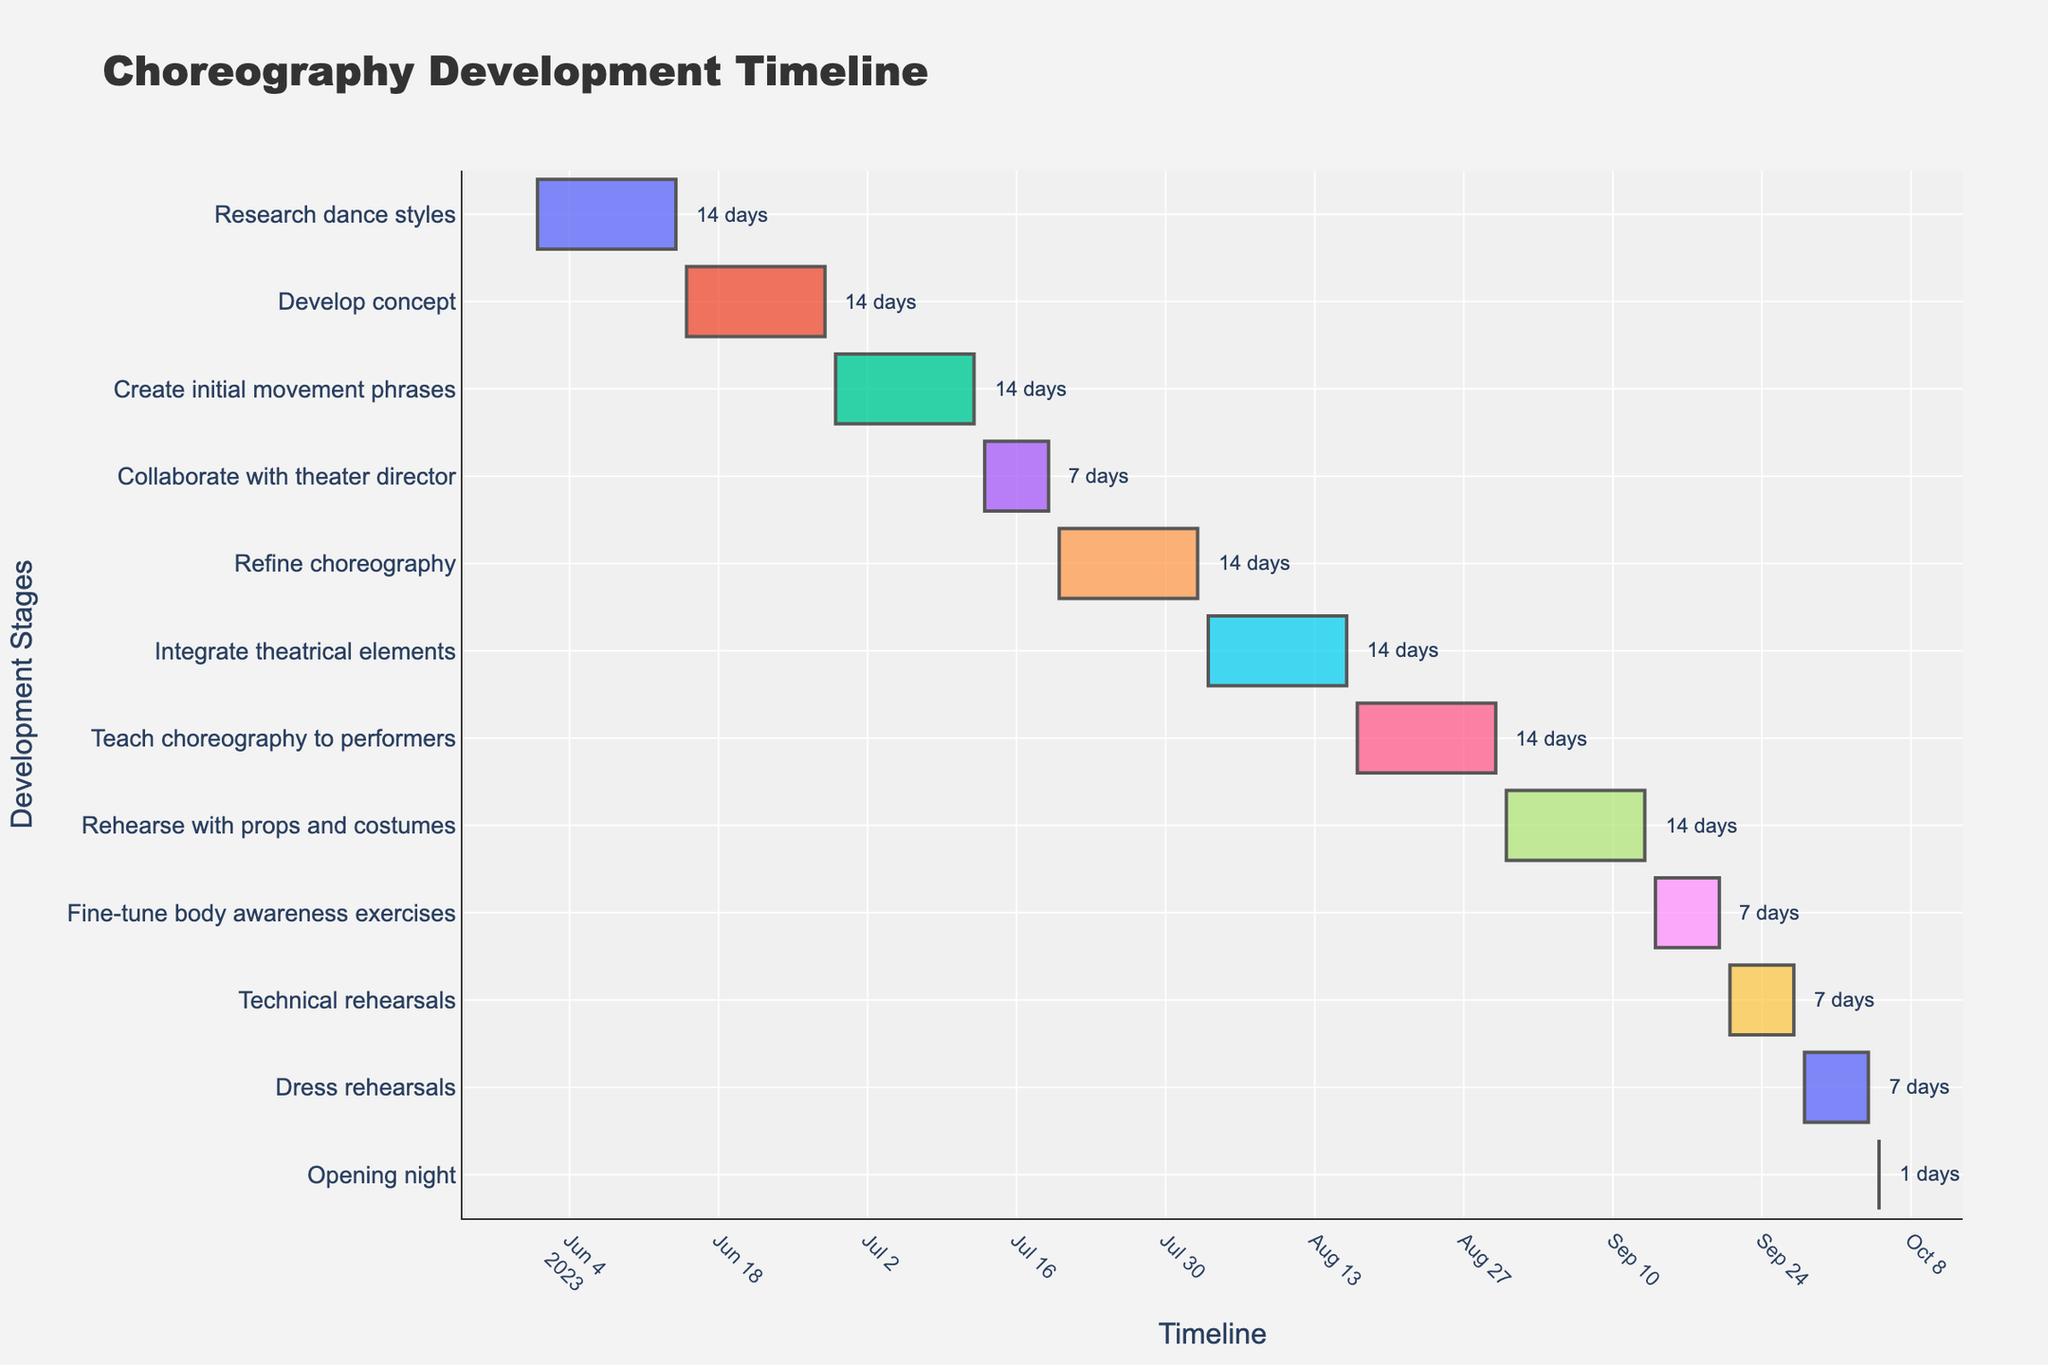What is the title of the Gantt chart? The title of the Gantt chart is usually displayed at the top. In this case, you can find it by looking at the top of the figure.
Answer: Choreography Development Timeline How many development stages are shown in the Gantt chart? Count the number of distinct tasks listed along the y-axis. Each task represents a different development stage.
Answer: 12 When does the "Integrate theatrical elements" stage start and end? Find the "Integrate theatrical elements" task on the y-axis and then look at the corresponding bar's start and end dates along the x-axis.
Answer: August 3, 2023 - August 16, 2023 Which stage has the shortest duration, and what is its duration? Identify the task with the shortest bar in the Gantt chart. Then, check the duration annotation next to it.
Answer: Opening night, 1 day What stages span across the month of August 2023? Look for tasks that have bars extending into or across the month of August 2023 along the x-axis. Note the relevant tasks.
Answer: Refine choreography, Integrate theatrical elements, Teach choreography to performers, Rehearse with props and costumes How long does the "Collaborate with theater director" stage last? Locate the "Collaborate with theater director" task on the chart and read the duration annotation next to it.
Answer: 7 days Which tasks have a duration of 14 days? Find all the tasks that have a duration annotation showing "14 days" next to their bars on the Gantt chart.
Answer: Research dance styles, Develop concept, Create initial movement phrases, Refine choreography, Integrate theatrical elements, Teach choreography to performers, Rehearse with props and costumes Which stage starts immediately after the "Create initial movement phrases" stage? Look at the end date of the "Create initial movement phrases" stage and identify the next task that starts immediately after this date along the x-axis.
Answer: Collaborate with theater director How many days does the entire choreography development process span from start to opening night? Calculate the total time from the start date of the first task to the end date of the last task by noting their respective dates.
Answer: 127 days Which stages are scheduled for exactly 7 days? Locate all stages that have duration annotations of "7 days" next to their bars on the Gantt chart.
Answer: Collaborate with theater director, Fine-tune body awareness exercises, Technical rehearsals, Dress rehearsals 